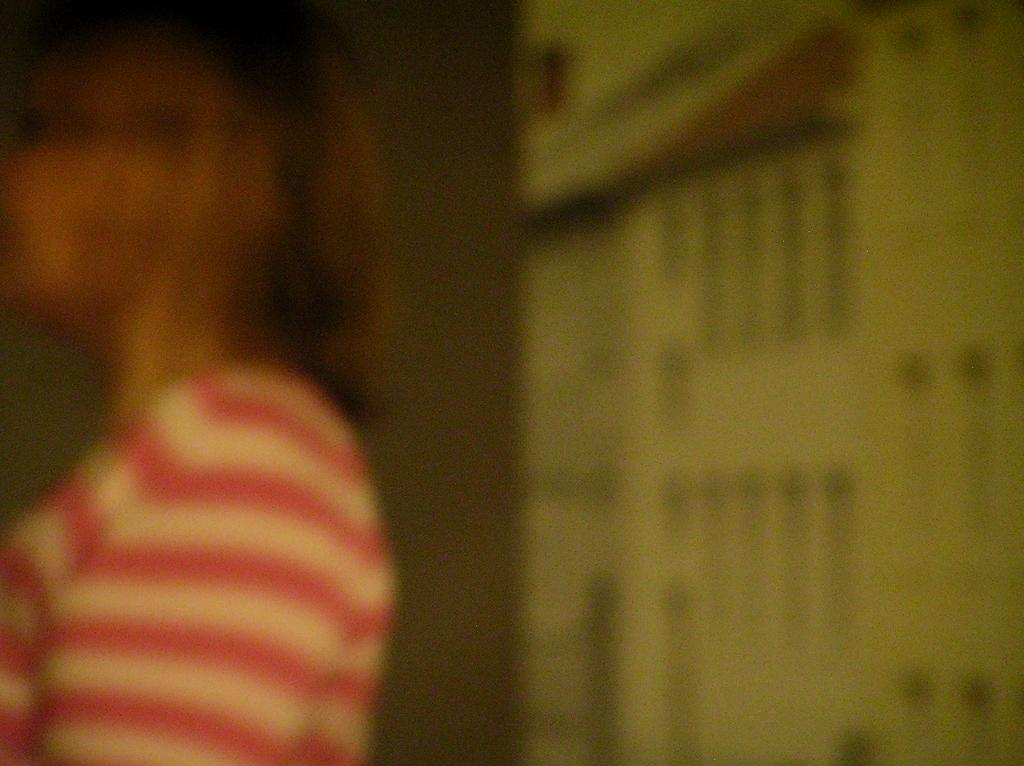Can you describe the quality of the image? The image is blurry. What can be seen in the image despite its blurriness? There is a woman in the image. What type of jam is the woman spreading on the coast in the image? There is no jam or coast present in the image; it only features a blurry woman. 